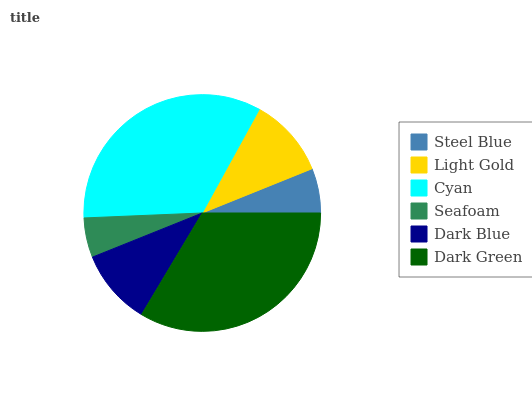Is Seafoam the minimum?
Answer yes or no. Yes. Is Cyan the maximum?
Answer yes or no. Yes. Is Light Gold the minimum?
Answer yes or no. No. Is Light Gold the maximum?
Answer yes or no. No. Is Light Gold greater than Steel Blue?
Answer yes or no. Yes. Is Steel Blue less than Light Gold?
Answer yes or no. Yes. Is Steel Blue greater than Light Gold?
Answer yes or no. No. Is Light Gold less than Steel Blue?
Answer yes or no. No. Is Light Gold the high median?
Answer yes or no. Yes. Is Dark Blue the low median?
Answer yes or no. Yes. Is Steel Blue the high median?
Answer yes or no. No. Is Dark Green the low median?
Answer yes or no. No. 